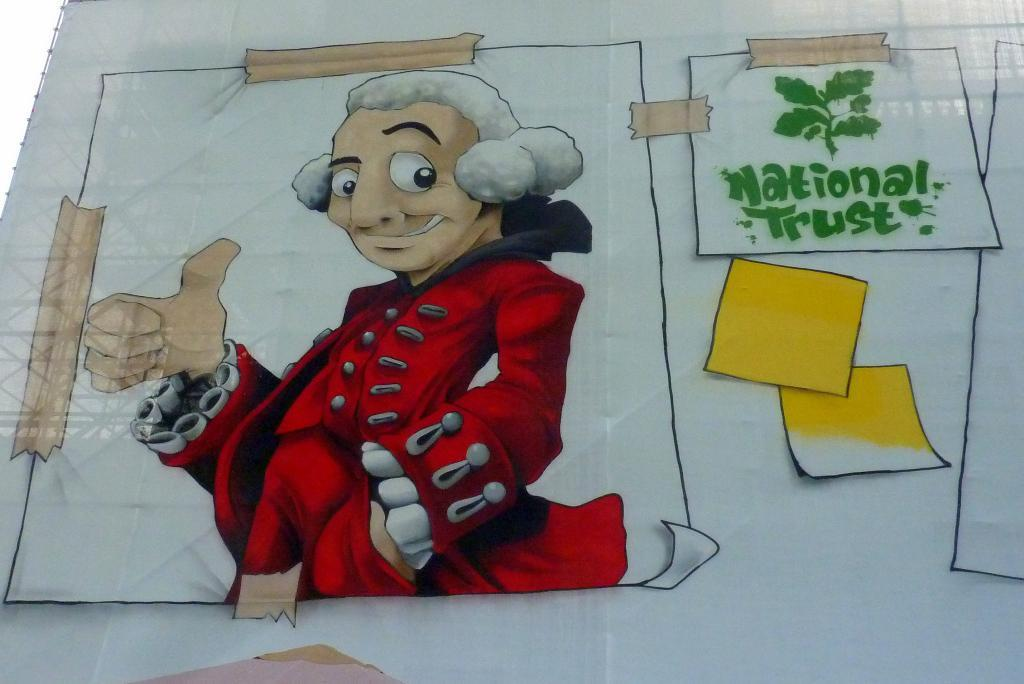<image>
Relay a brief, clear account of the picture shown. A cartoon character sits next to a sign that says "national trust" 